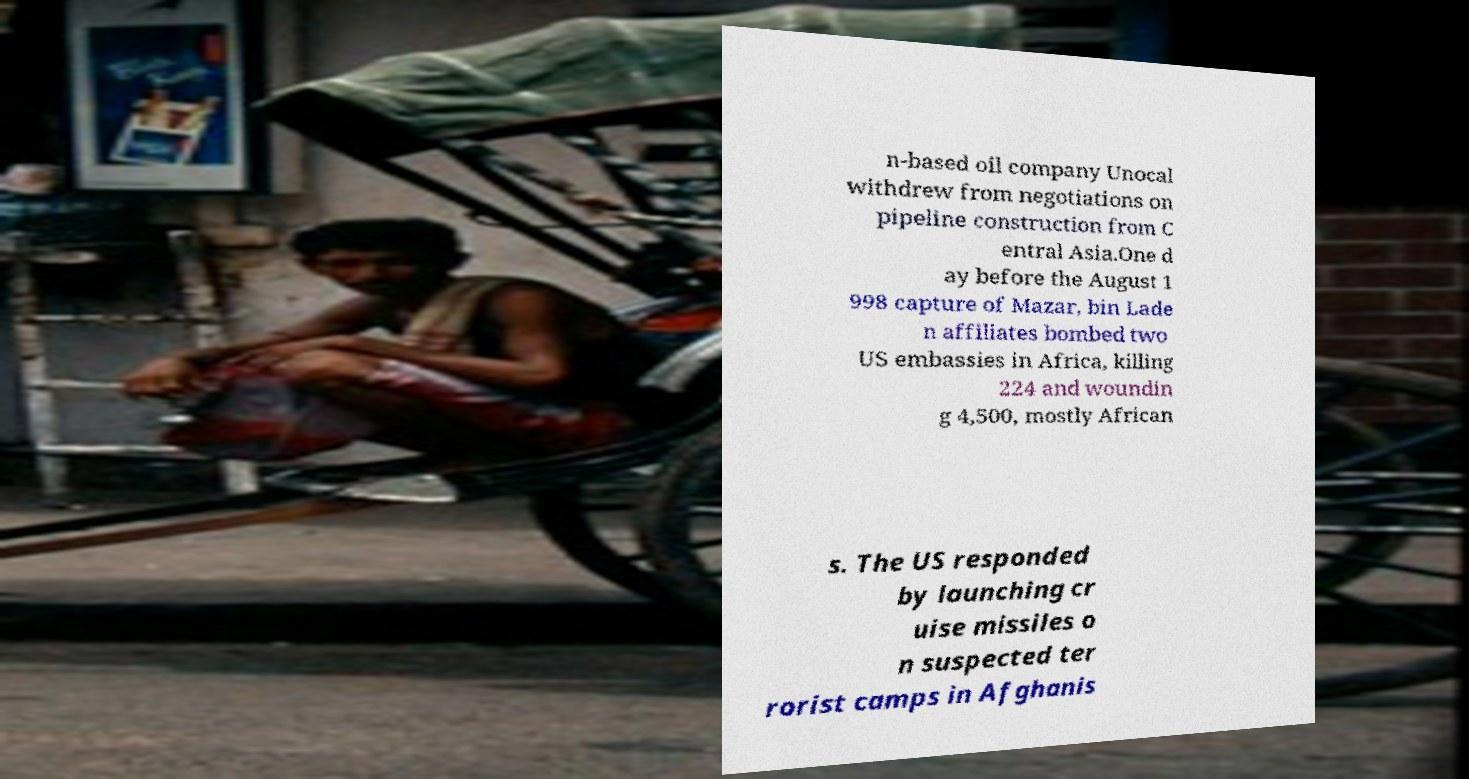Please identify and transcribe the text found in this image. n-based oil company Unocal withdrew from negotiations on pipeline construction from C entral Asia.One d ay before the August 1 998 capture of Mazar, bin Lade n affiliates bombed two US embassies in Africa, killing 224 and woundin g 4,500, mostly African s. The US responded by launching cr uise missiles o n suspected ter rorist camps in Afghanis 